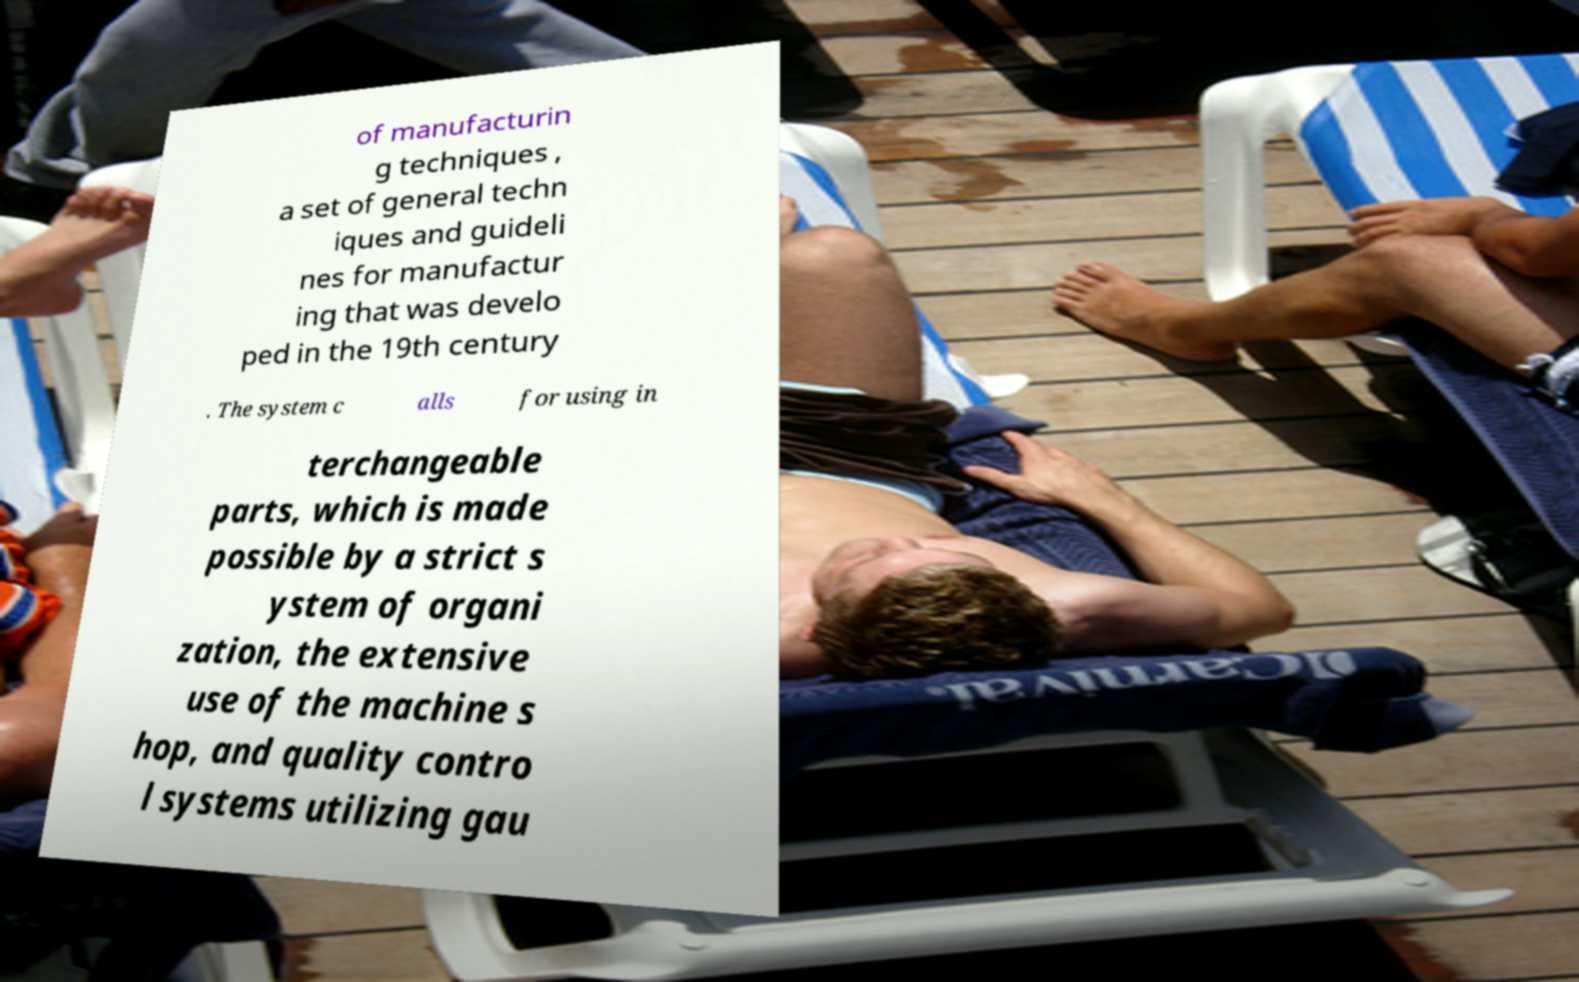Could you assist in decoding the text presented in this image and type it out clearly? of manufacturin g techniques , a set of general techn iques and guideli nes for manufactur ing that was develo ped in the 19th century . The system c alls for using in terchangeable parts, which is made possible by a strict s ystem of organi zation, the extensive use of the machine s hop, and quality contro l systems utilizing gau 